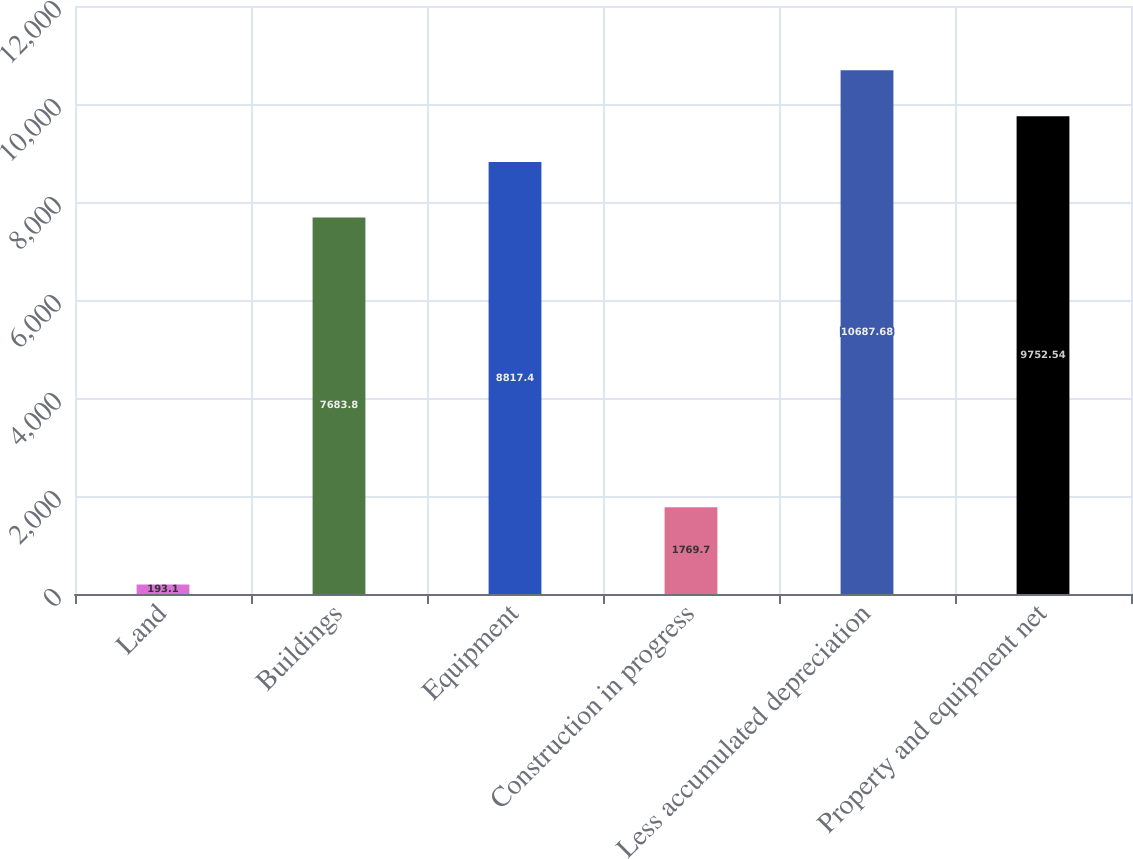Convert chart. <chart><loc_0><loc_0><loc_500><loc_500><bar_chart><fcel>Land<fcel>Buildings<fcel>Equipment<fcel>Construction in progress<fcel>Less accumulated depreciation<fcel>Property and equipment net<nl><fcel>193.1<fcel>7683.8<fcel>8817.4<fcel>1769.7<fcel>10687.7<fcel>9752.54<nl></chart> 